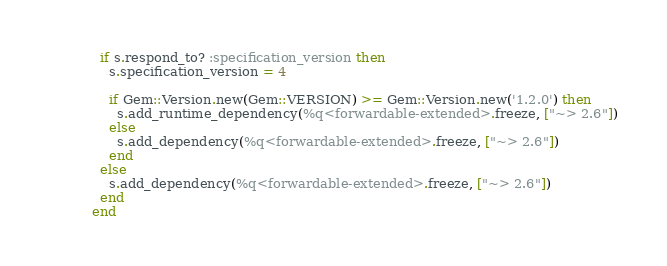Convert code to text. <code><loc_0><loc_0><loc_500><loc_500><_Ruby_>  if s.respond_to? :specification_version then
    s.specification_version = 4

    if Gem::Version.new(Gem::VERSION) >= Gem::Version.new('1.2.0') then
      s.add_runtime_dependency(%q<forwardable-extended>.freeze, ["~> 2.6"])
    else
      s.add_dependency(%q<forwardable-extended>.freeze, ["~> 2.6"])
    end
  else
    s.add_dependency(%q<forwardable-extended>.freeze, ["~> 2.6"])
  end
end
</code> 